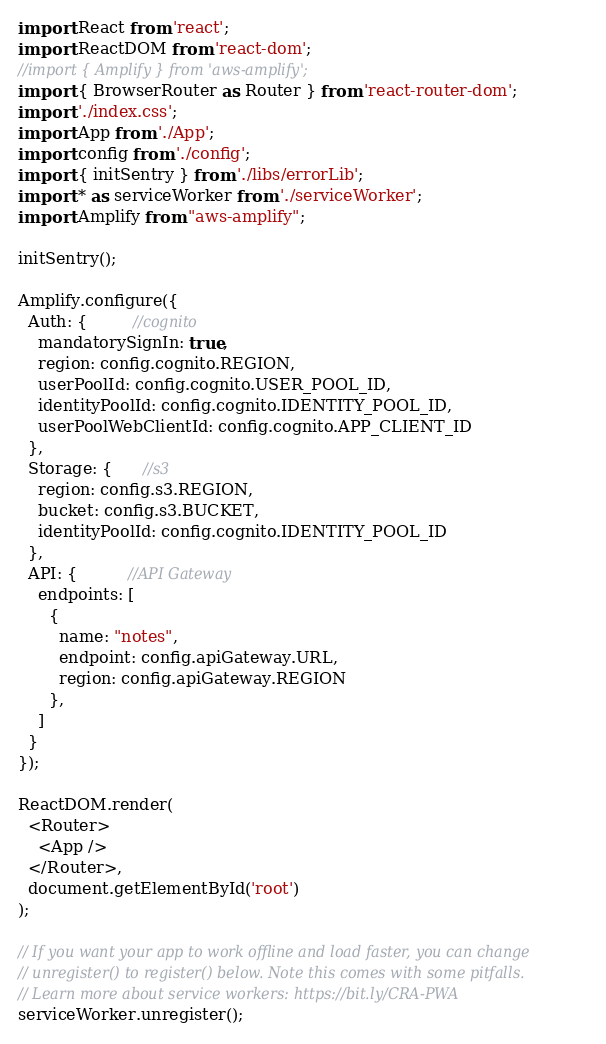<code> <loc_0><loc_0><loc_500><loc_500><_JavaScript_>import React from 'react';
import ReactDOM from 'react-dom';
//import { Amplify } from 'aws-amplify';
import { BrowserRouter as Router } from 'react-router-dom';
import './index.css';
import App from './App';
import config from './config';
import { initSentry } from './libs/errorLib';
import * as serviceWorker from './serviceWorker';
import Amplify from "aws-amplify";

initSentry();

Amplify.configure({
  Auth: {         //cognito
    mandatorySignIn: true,
    region: config.cognito.REGION,
    userPoolId: config.cognito.USER_POOL_ID,
    identityPoolId: config.cognito.IDENTITY_POOL_ID,
    userPoolWebClientId: config.cognito.APP_CLIENT_ID
  },
  Storage: {      //s3
    region: config.s3.REGION,
    bucket: config.s3.BUCKET,
    identityPoolId: config.cognito.IDENTITY_POOL_ID
  },
  API: {          //API Gateway
    endpoints: [
      {
        name: "notes",
        endpoint: config.apiGateway.URL,
        region: config.apiGateway.REGION
      },
    ]
  }
});

ReactDOM.render(
  <Router>
    <App />
  </Router>,
  document.getElementById('root')
);

// If you want your app to work offline and load faster, you can change
// unregister() to register() below. Note this comes with some pitfalls.
// Learn more about service workers: https://bit.ly/CRA-PWA
serviceWorker.unregister();
</code> 